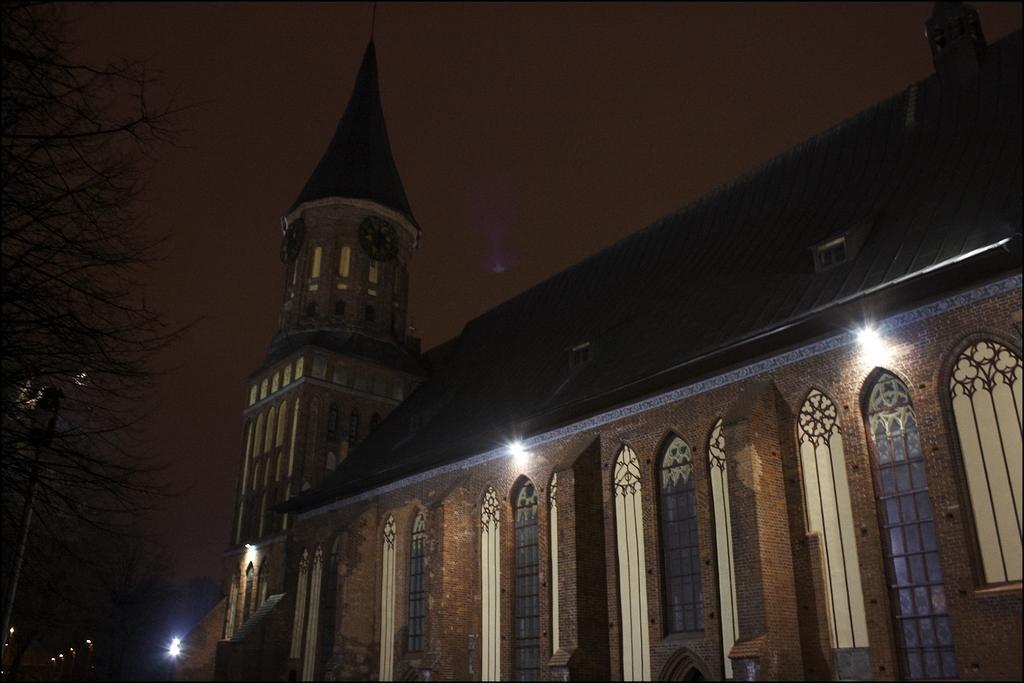Describe this image in one or two sentences. In this image we can see a building with windows, a clock tower, lights, some trees, a pole and the sky. 